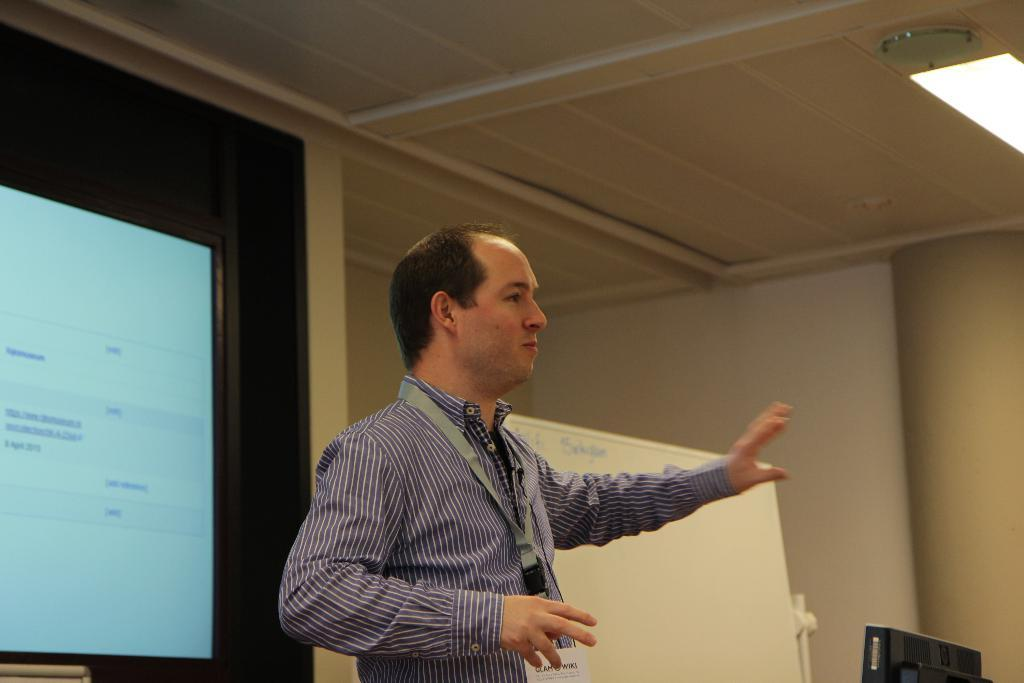What is the main subject of the image? There is a person standing in the image. What is the person wearing? The person is wearing a purple shirt. What can be seen in the background of the image? There is a white color board and a projector screen in the background. What type of snake is crawling on the person's chin in the image? There is no snake present in the image, and the person's chin is not mentioned in the provided facts. 